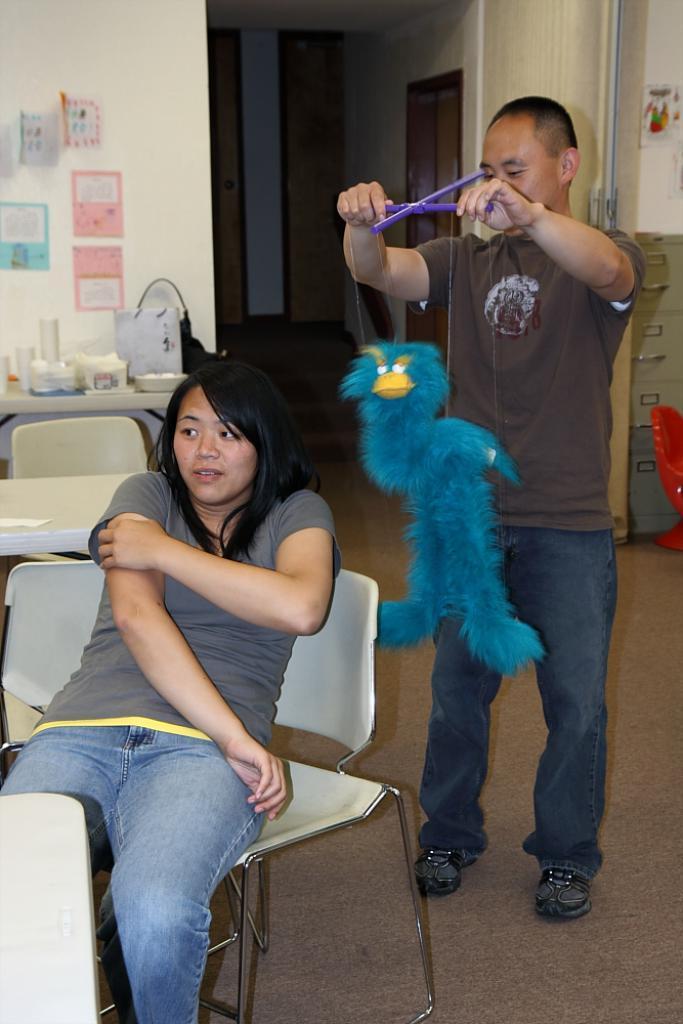Can you describe this image briefly? In this image there is a person sitting on the chair, a person standing and holding a puppet, chairs, glasses and some objects on the table, carpet, papers stick to the wall, cupboard, door. 